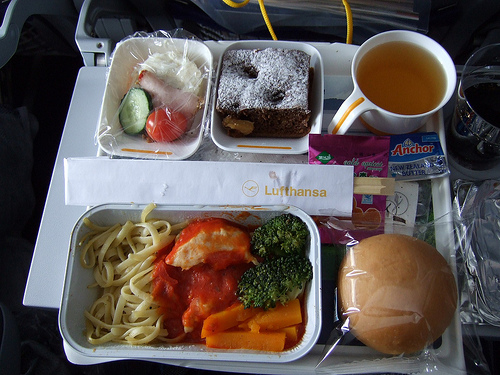<image>
Can you confirm if the noodles is under the juice? No. The noodles is not positioned under the juice. The vertical relationship between these objects is different. Is the chopsticks in the sleeve? Yes. The chopsticks is contained within or inside the sleeve, showing a containment relationship. 